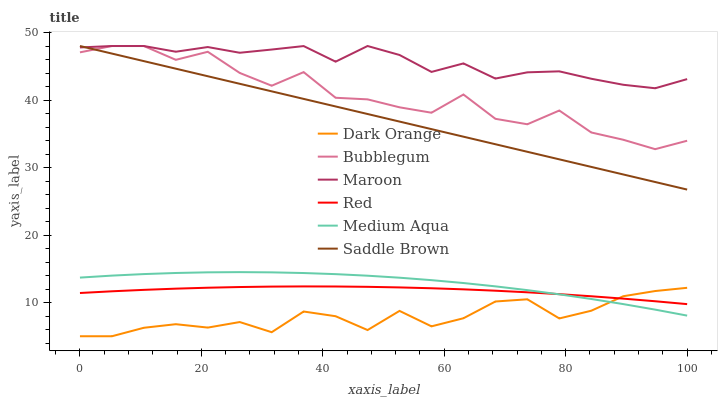Does Dark Orange have the minimum area under the curve?
Answer yes or no. Yes. Does Maroon have the maximum area under the curve?
Answer yes or no. Yes. Does Medium Aqua have the minimum area under the curve?
Answer yes or no. No. Does Medium Aqua have the maximum area under the curve?
Answer yes or no. No. Is Saddle Brown the smoothest?
Answer yes or no. Yes. Is Bubblegum the roughest?
Answer yes or no. Yes. Is Maroon the smoothest?
Answer yes or no. No. Is Maroon the roughest?
Answer yes or no. No. Does Dark Orange have the lowest value?
Answer yes or no. Yes. Does Medium Aqua have the lowest value?
Answer yes or no. No. Does Saddle Brown have the highest value?
Answer yes or no. Yes. Does Medium Aqua have the highest value?
Answer yes or no. No. Is Medium Aqua less than Bubblegum?
Answer yes or no. Yes. Is Bubblegum greater than Dark Orange?
Answer yes or no. Yes. Does Maroon intersect Saddle Brown?
Answer yes or no. Yes. Is Maroon less than Saddle Brown?
Answer yes or no. No. Is Maroon greater than Saddle Brown?
Answer yes or no. No. Does Medium Aqua intersect Bubblegum?
Answer yes or no. No. 